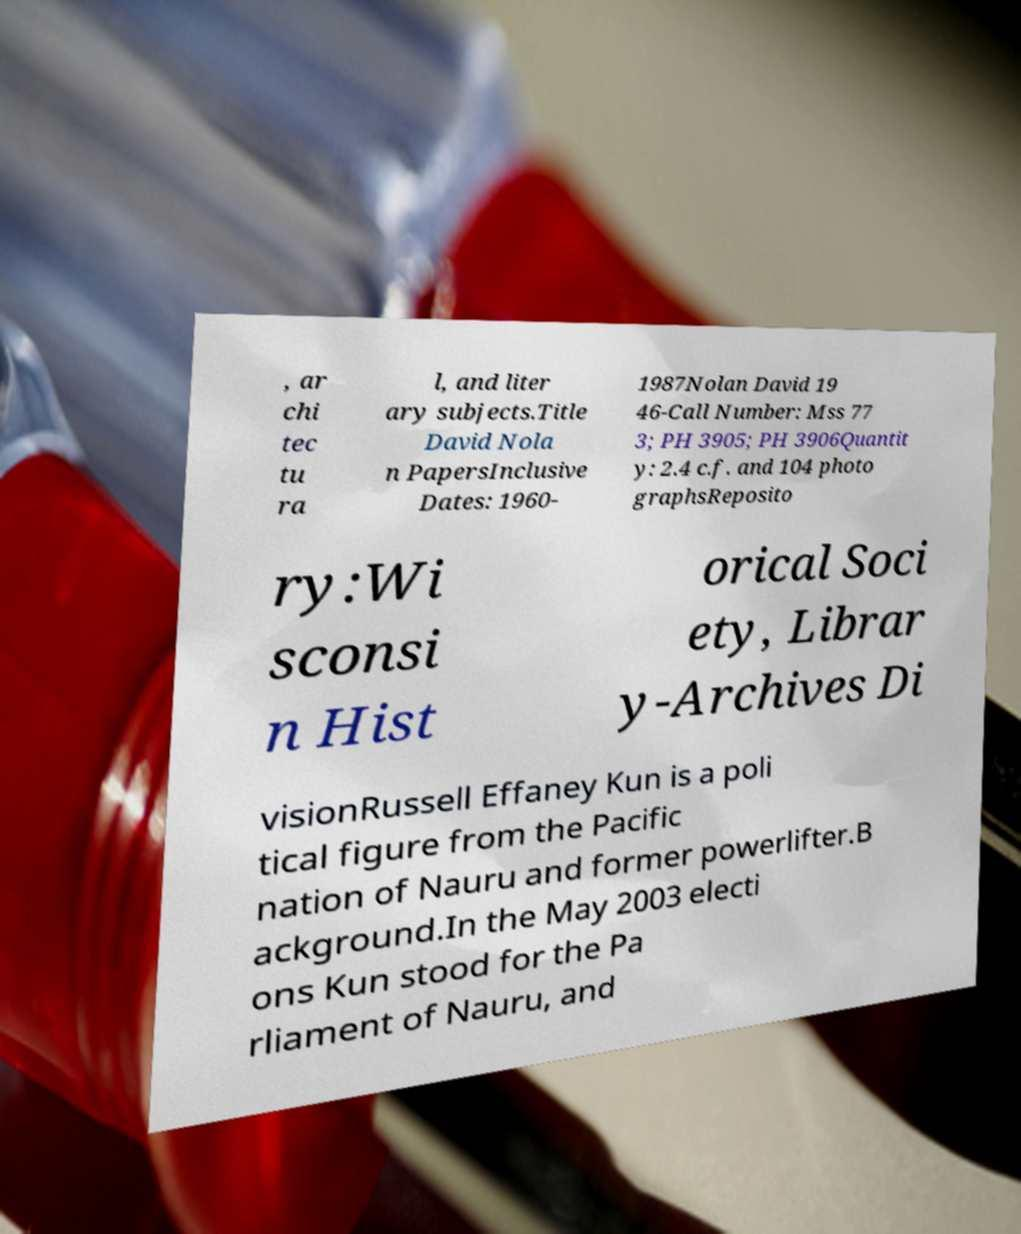Could you extract and type out the text from this image? , ar chi tec tu ra l, and liter ary subjects.Title David Nola n PapersInclusive Dates: 1960- 1987Nolan David 19 46-Call Number: Mss 77 3; PH 3905; PH 3906Quantit y: 2.4 c.f. and 104 photo graphsReposito ry:Wi sconsi n Hist orical Soci ety, Librar y-Archives Di visionRussell Effaney Kun is a poli tical figure from the Pacific nation of Nauru and former powerlifter.B ackground.In the May 2003 electi ons Kun stood for the Pa rliament of Nauru, and 